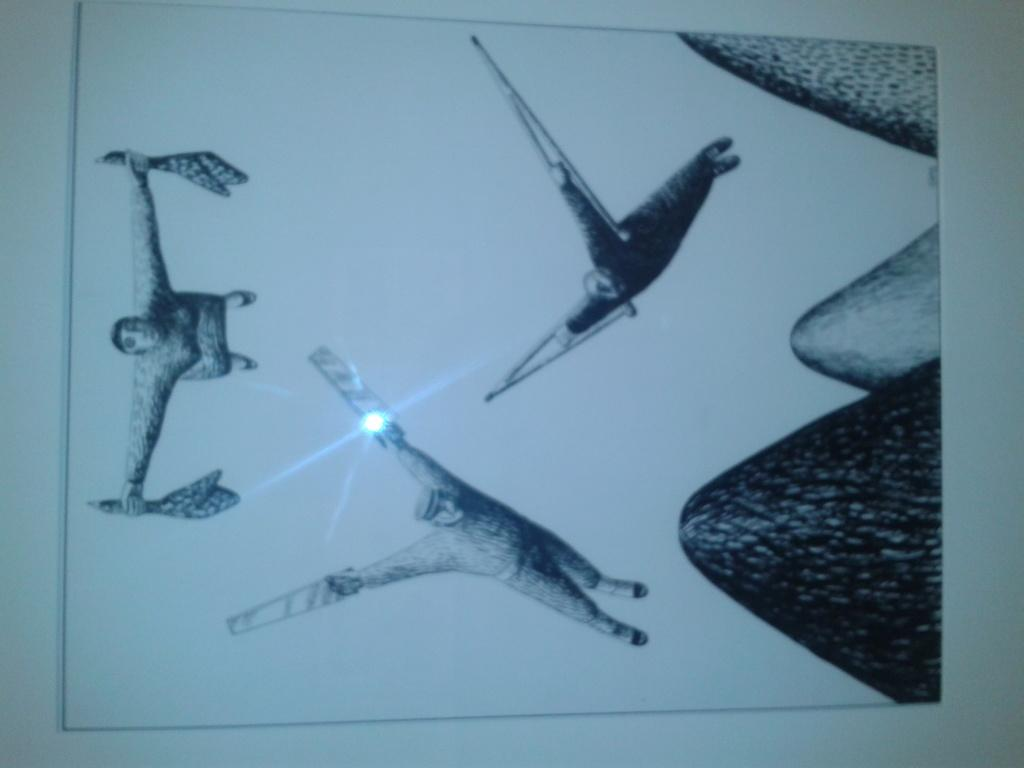What is the main subject of the image? The main subject of the image is a frame. What is inside the frame? The frame contains a depiction of persons. What type of pancake is being served to the women in the image? There are no women or pancakes present in the image; it only contains a frame with a depiction of persons. 